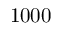<formula> <loc_0><loc_0><loc_500><loc_500>1 0 0 0</formula> 